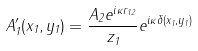<formula> <loc_0><loc_0><loc_500><loc_500>A ^ { \prime } _ { 1 } ( x _ { 1 } , y _ { 1 } ) = \frac { A _ { 2 } e ^ { i \kappa r _ { 1 2 } } } { z _ { 1 } } e ^ { i \kappa \delta ( x _ { 1 } , y _ { 1 } ) }</formula> 